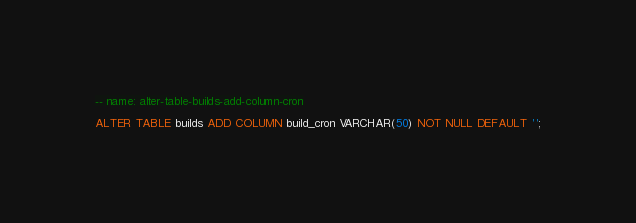<code> <loc_0><loc_0><loc_500><loc_500><_SQL_>-- name: alter-table-builds-add-column-cron

ALTER TABLE builds ADD COLUMN build_cron VARCHAR(50) NOT NULL DEFAULT '';
</code> 